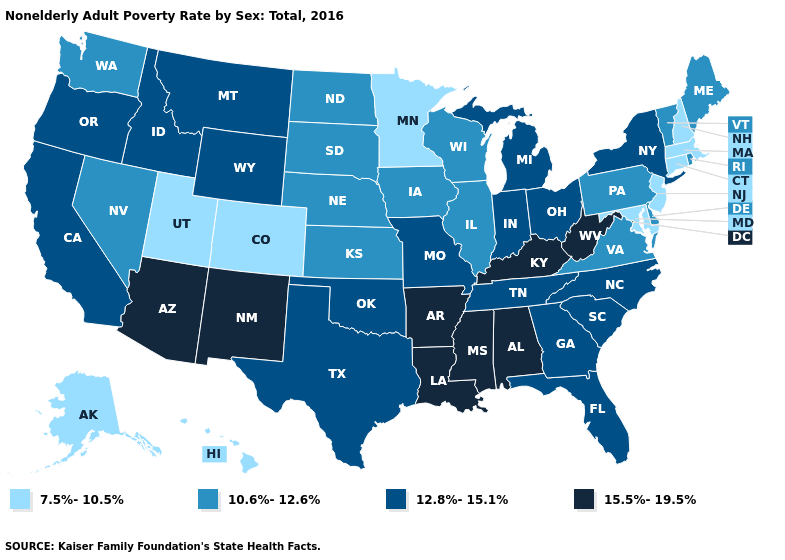Which states have the lowest value in the USA?
Short answer required. Alaska, Colorado, Connecticut, Hawaii, Maryland, Massachusetts, Minnesota, New Hampshire, New Jersey, Utah. What is the highest value in states that border North Carolina?
Give a very brief answer. 12.8%-15.1%. Does Hawaii have the lowest value in the USA?
Keep it brief. Yes. Name the states that have a value in the range 15.5%-19.5%?
Give a very brief answer. Alabama, Arizona, Arkansas, Kentucky, Louisiana, Mississippi, New Mexico, West Virginia. Does Alabama have the same value as Arizona?
Answer briefly. Yes. Does the first symbol in the legend represent the smallest category?
Write a very short answer. Yes. Does Nevada have a lower value than Arizona?
Keep it brief. Yes. What is the lowest value in the West?
Write a very short answer. 7.5%-10.5%. What is the value of Minnesota?
Quick response, please. 7.5%-10.5%. Which states have the lowest value in the West?
Concise answer only. Alaska, Colorado, Hawaii, Utah. What is the highest value in the MidWest ?
Keep it brief. 12.8%-15.1%. How many symbols are there in the legend?
Be succinct. 4. How many symbols are there in the legend?
Keep it brief. 4. Does Wyoming have the lowest value in the West?
Write a very short answer. No. Name the states that have a value in the range 10.6%-12.6%?
Be succinct. Delaware, Illinois, Iowa, Kansas, Maine, Nebraska, Nevada, North Dakota, Pennsylvania, Rhode Island, South Dakota, Vermont, Virginia, Washington, Wisconsin. 